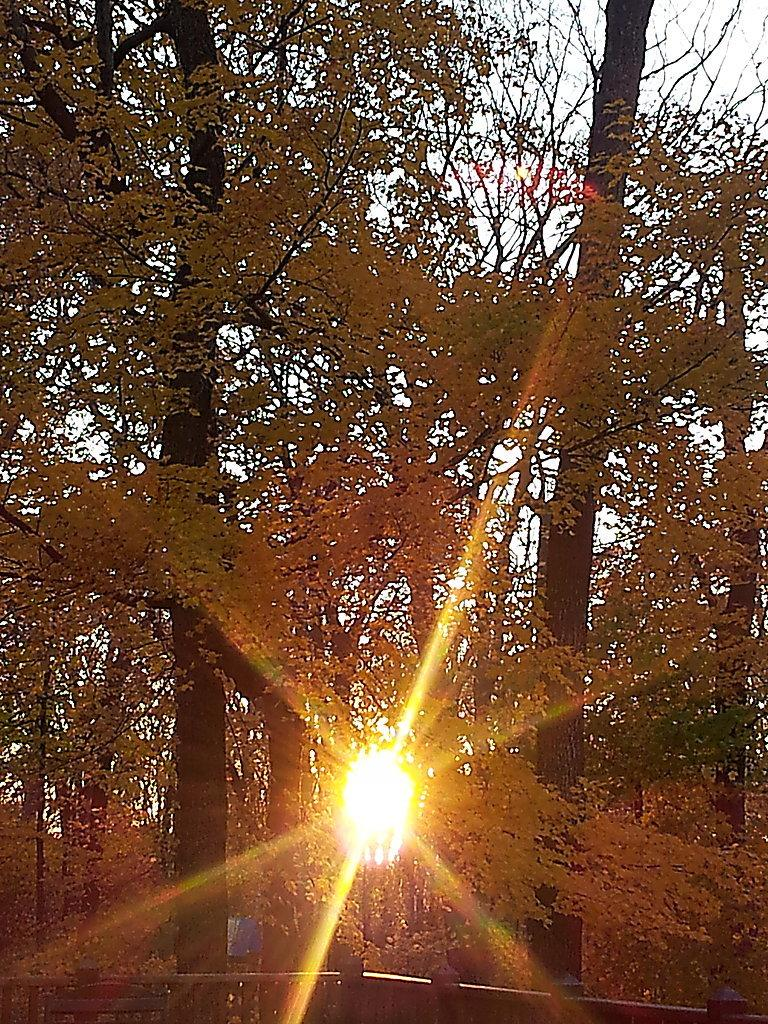What type of vegetation can be seen in the image? There are trees in the image. What celestial body is visible in the image? The sun is visible in the image. What else can be seen in the sky in the image? The sky is visible in the image. What type of jail can be seen in the image? There is no jail present in the image. What kind of rock is visible in the image? There is no rock visible in the image. 